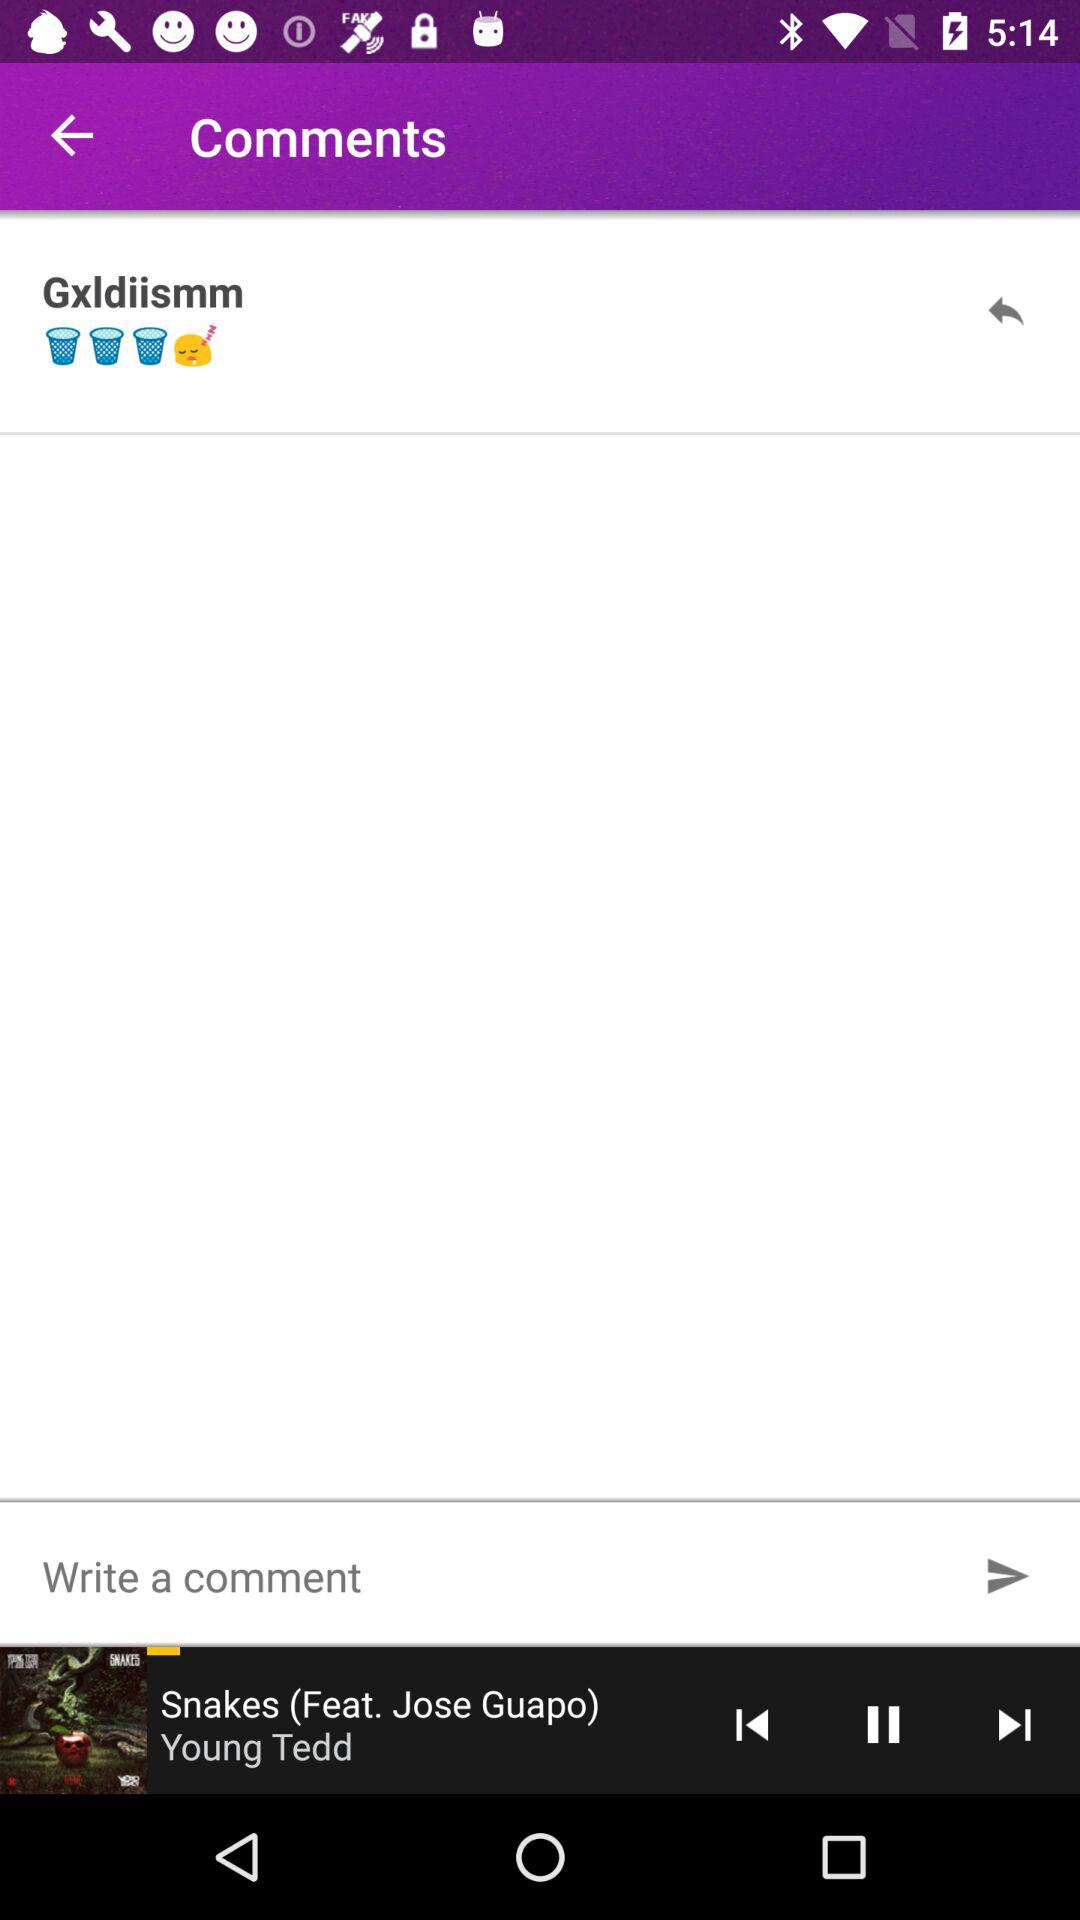Which song is playing? The playing song is "Snakes". 